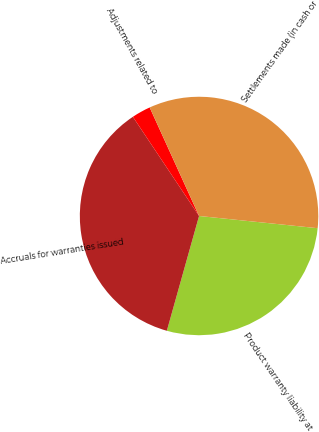Convert chart to OTSL. <chart><loc_0><loc_0><loc_500><loc_500><pie_chart><fcel>Product warranty liability at<fcel>Accruals for warranties issued<fcel>Adjustments related to<fcel>Settlements made (in cash or<nl><fcel>27.72%<fcel>36.28%<fcel>2.57%<fcel>33.43%<nl></chart> 